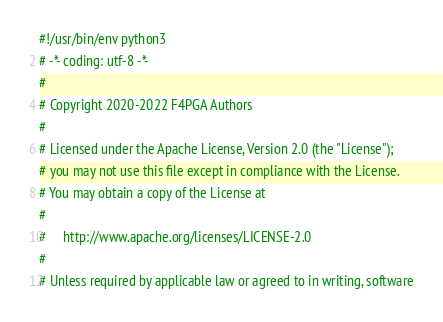Convert code to text. <code><loc_0><loc_0><loc_500><loc_500><_Python_>#!/usr/bin/env python3
# -*- coding: utf-8 -*-
#
# Copyright 2020-2022 F4PGA Authors
#
# Licensed under the Apache License, Version 2.0 (the "License");
# you may not use this file except in compliance with the License.
# You may obtain a copy of the License at
#
#     http://www.apache.org/licenses/LICENSE-2.0
#
# Unless required by applicable law or agreed to in writing, software</code> 